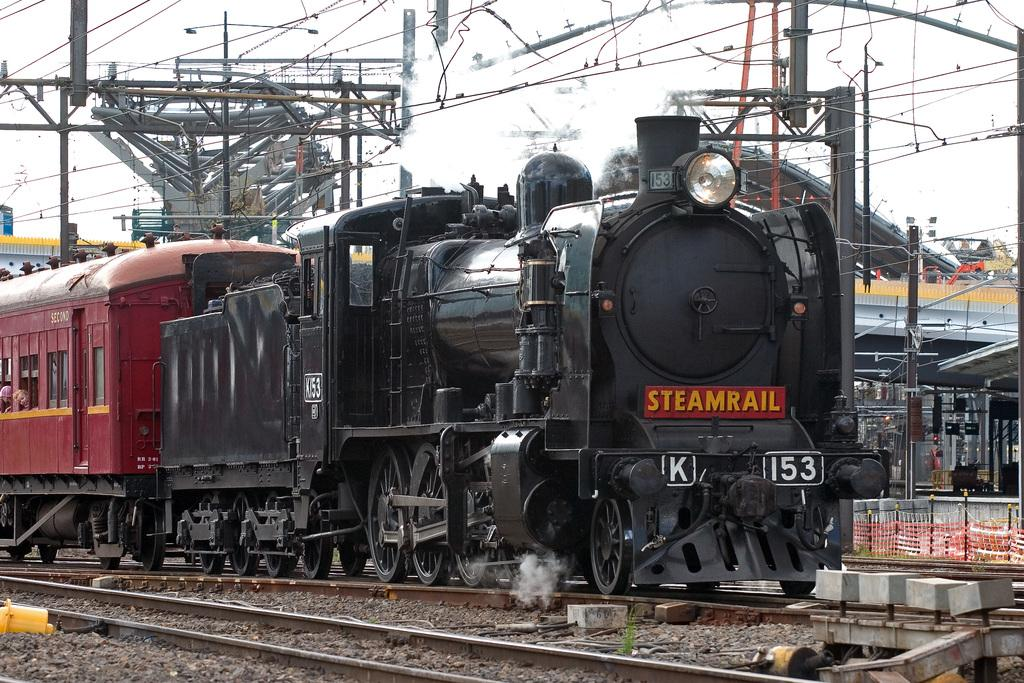What type of vehicle is in the image? There is a steam engine in the image. Is there any other vehicle or object attached to the steam engine? Yes, a coach is attached to the steam engine. Where are the steam engine and coach located? They are on a rail track. What else can be seen in the image besides the steam engine and coach? There are poles visible in the image, which might be current polls, and there is a shed in the image. What type of suit is the steam engine wearing in the image? Steam engines do not wear suits; they are inanimate objects. 